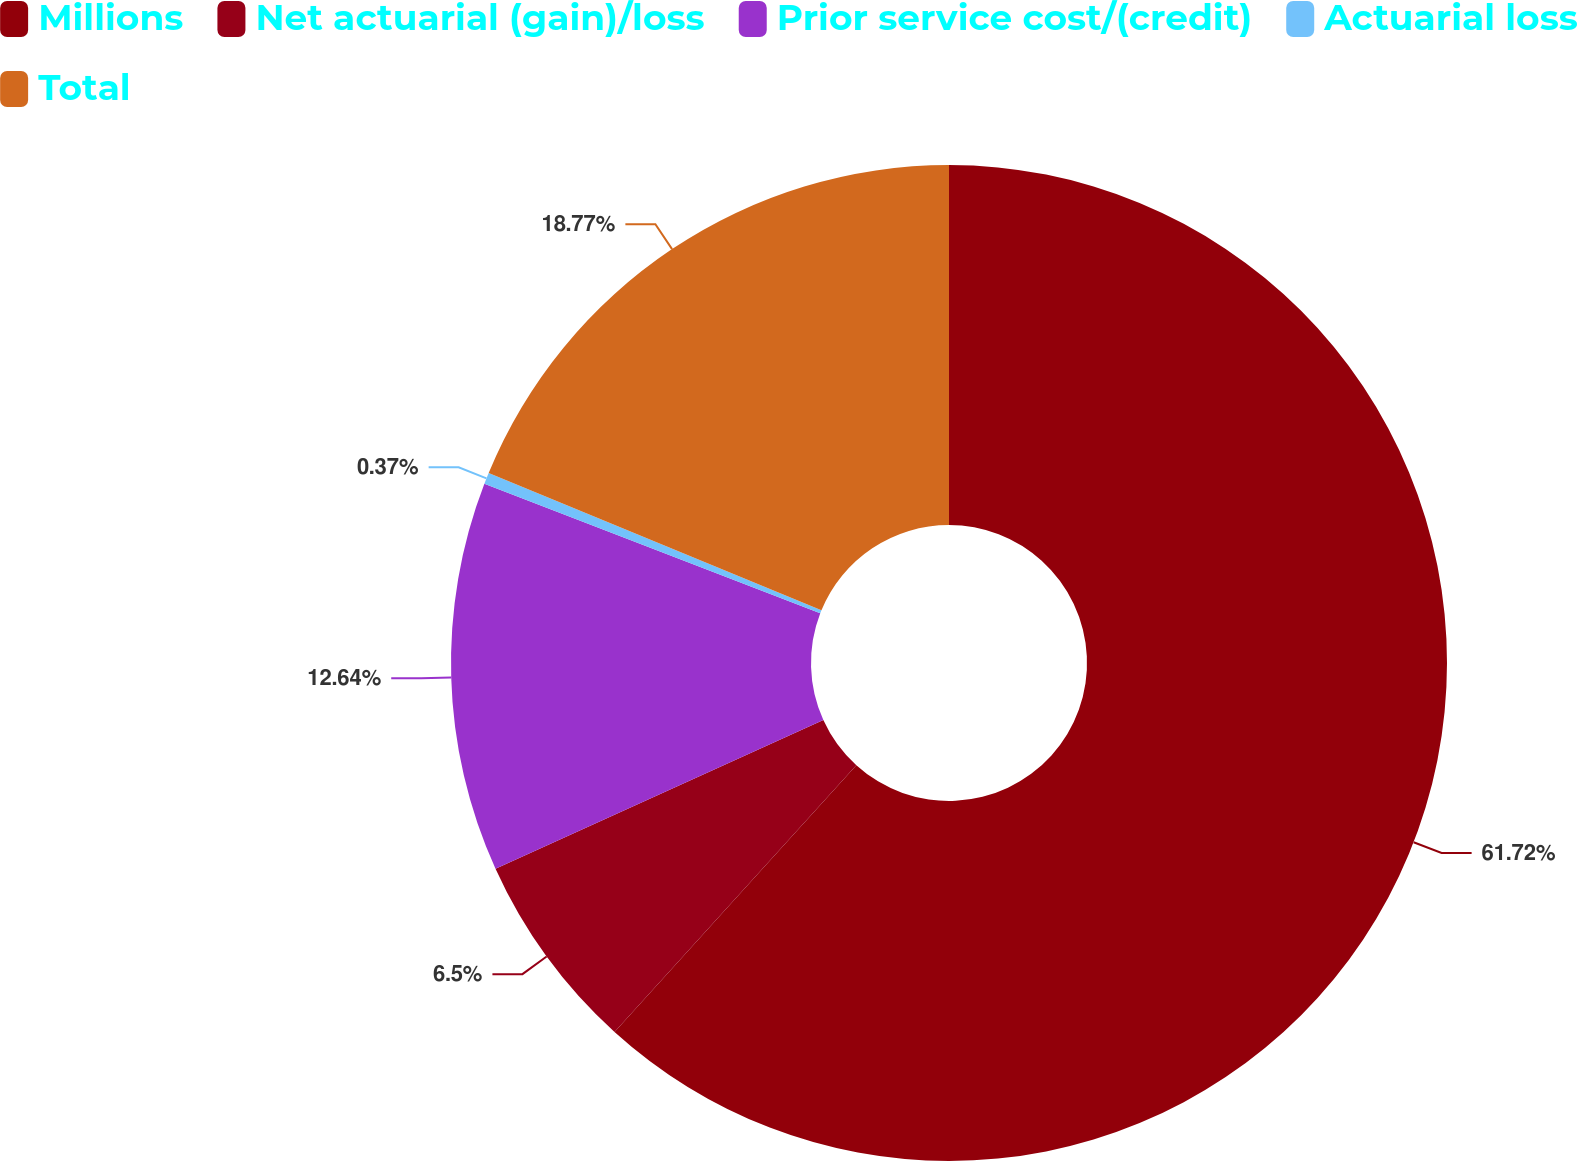Convert chart. <chart><loc_0><loc_0><loc_500><loc_500><pie_chart><fcel>Millions<fcel>Net actuarial (gain)/loss<fcel>Prior service cost/(credit)<fcel>Actuarial loss<fcel>Total<nl><fcel>61.72%<fcel>6.5%<fcel>12.64%<fcel>0.37%<fcel>18.77%<nl></chart> 